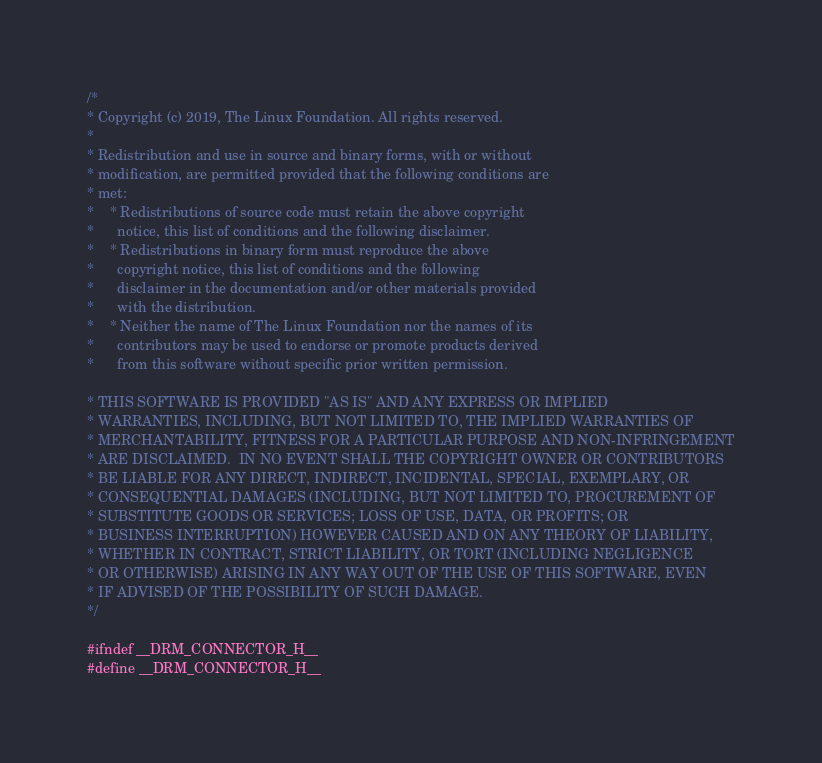Convert code to text. <code><loc_0><loc_0><loc_500><loc_500><_C_>/*
* Copyright (c) 2019, The Linux Foundation. All rights reserved.
*
* Redistribution and use in source and binary forms, with or without
* modification, are permitted provided that the following conditions are
* met:
*    * Redistributions of source code must retain the above copyright
*      notice, this list of conditions and the following disclaimer.
*    * Redistributions in binary form must reproduce the above
*      copyright notice, this list of conditions and the following
*      disclaimer in the documentation and/or other materials provided
*      with the distribution.
*    * Neither the name of The Linux Foundation nor the names of its
*      contributors may be used to endorse or promote products derived
*      from this software without specific prior written permission.

* THIS SOFTWARE IS PROVIDED "AS IS" AND ANY EXPRESS OR IMPLIED
* WARRANTIES, INCLUDING, BUT NOT LIMITED TO, THE IMPLIED WARRANTIES OF
* MERCHANTABILITY, FITNESS FOR A PARTICULAR PURPOSE AND NON-INFRINGEMENT
* ARE DISCLAIMED.  IN NO EVENT SHALL THE COPYRIGHT OWNER OR CONTRIBUTORS
* BE LIABLE FOR ANY DIRECT, INDIRECT, INCIDENTAL, SPECIAL, EXEMPLARY, OR
* CONSEQUENTIAL DAMAGES (INCLUDING, BUT NOT LIMITED TO, PROCUREMENT OF
* SUBSTITUTE GOODS OR SERVICES; LOSS OF USE, DATA, OR PROFITS; OR
* BUSINESS INTERRUPTION) HOWEVER CAUSED AND ON ANY THEORY OF LIABILITY,
* WHETHER IN CONTRACT, STRICT LIABILITY, OR TORT (INCLUDING NEGLIGENCE
* OR OTHERWISE) ARISING IN ANY WAY OUT OF THE USE OF THIS SOFTWARE, EVEN
* IF ADVISED OF THE POSSIBILITY OF SUCH DAMAGE.
*/

#ifndef __DRM_CONNECTOR_H__
#define __DRM_CONNECTOR_H__
</code> 